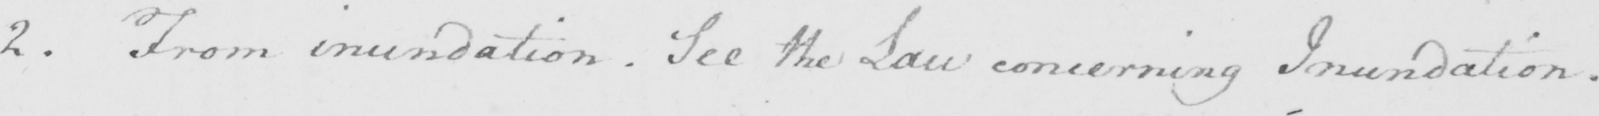Please provide the text content of this handwritten line. 2 . From inundation . See the Law concerning Inundation . 